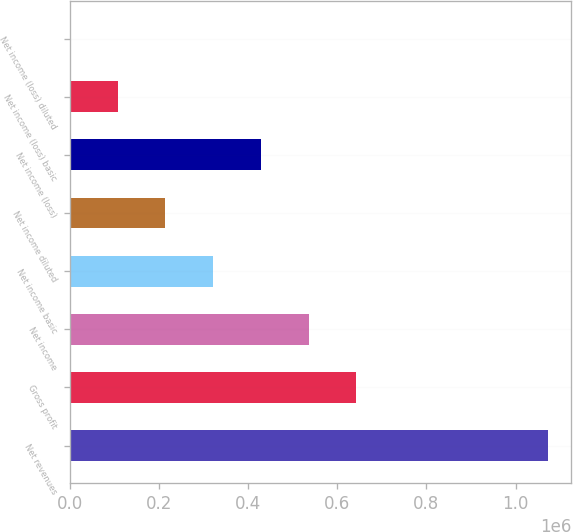<chart> <loc_0><loc_0><loc_500><loc_500><bar_chart><fcel>Net revenues<fcel>Gross profit<fcel>Net income<fcel>Net income basic<fcel>Net income diluted<fcel>Net income (loss)<fcel>Net income (loss) basic<fcel>Net income (loss) diluted<nl><fcel>1.07185e+06<fcel>643110<fcel>535925<fcel>321555<fcel>214370<fcel>428740<fcel>107185<fcel>0.56<nl></chart> 